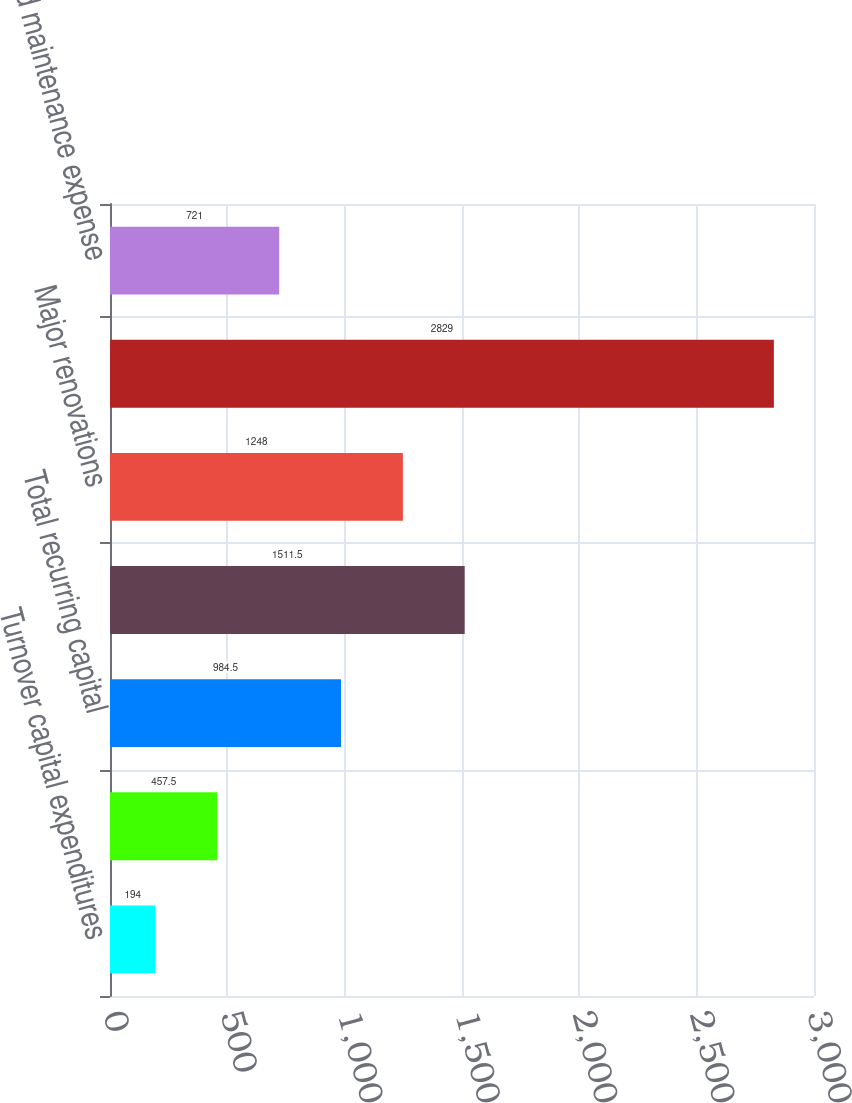Convert chart to OTSL. <chart><loc_0><loc_0><loc_500><loc_500><bar_chart><fcel>Turnover capital expenditures<fcel>Asset preservation<fcel>Total recurring capital<fcel>Revenue enhancing improvements<fcel>Major renovations<fcel>Total capital expenditures<fcel>Repair and maintenance expense<nl><fcel>194<fcel>457.5<fcel>984.5<fcel>1511.5<fcel>1248<fcel>2829<fcel>721<nl></chart> 